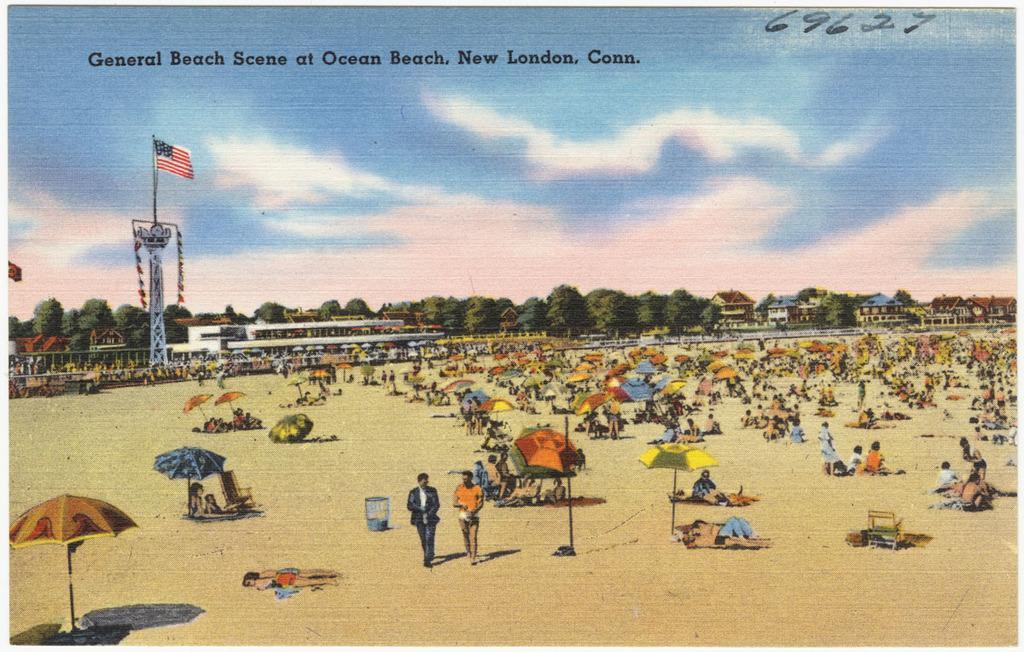How would you summarize this image in a sentence or two? In this image there is a portrait, in this there are people doing different activities and there are umbrellas, trees, tower on that tower there is a flag at the top there is text and the sky. 